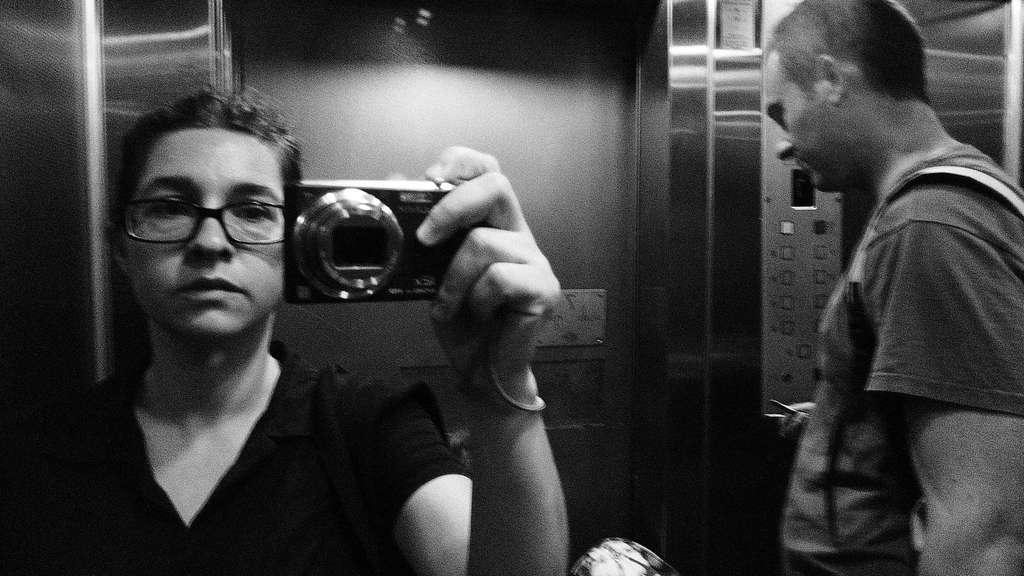Who is the main subject in the image? There is a woman in the image. What is the woman holding in her hand? The woman is holding a camera with her hand. What accessory is the woman wearing? The woman is wearing spectacles. Who else is present in the image? There is a man in the image. What can be seen in the background of the image? There is a lift in the background of the image. How many dogs are present in the image? There are no dogs present in the image. Who is the woman's friend in the image? The provided facts do not mention any friends or relationships between the people in the image. 